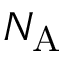Convert formula to latex. <formula><loc_0><loc_0><loc_500><loc_500>N _ { A }</formula> 